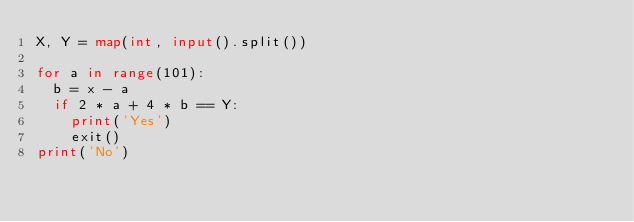<code> <loc_0><loc_0><loc_500><loc_500><_Python_>X, Y = map(int, input().split())

for a in range(101):
  b = x - a
  if 2 * a + 4 * b == Y:
    print('Yes')
    exit()
print('No')</code> 